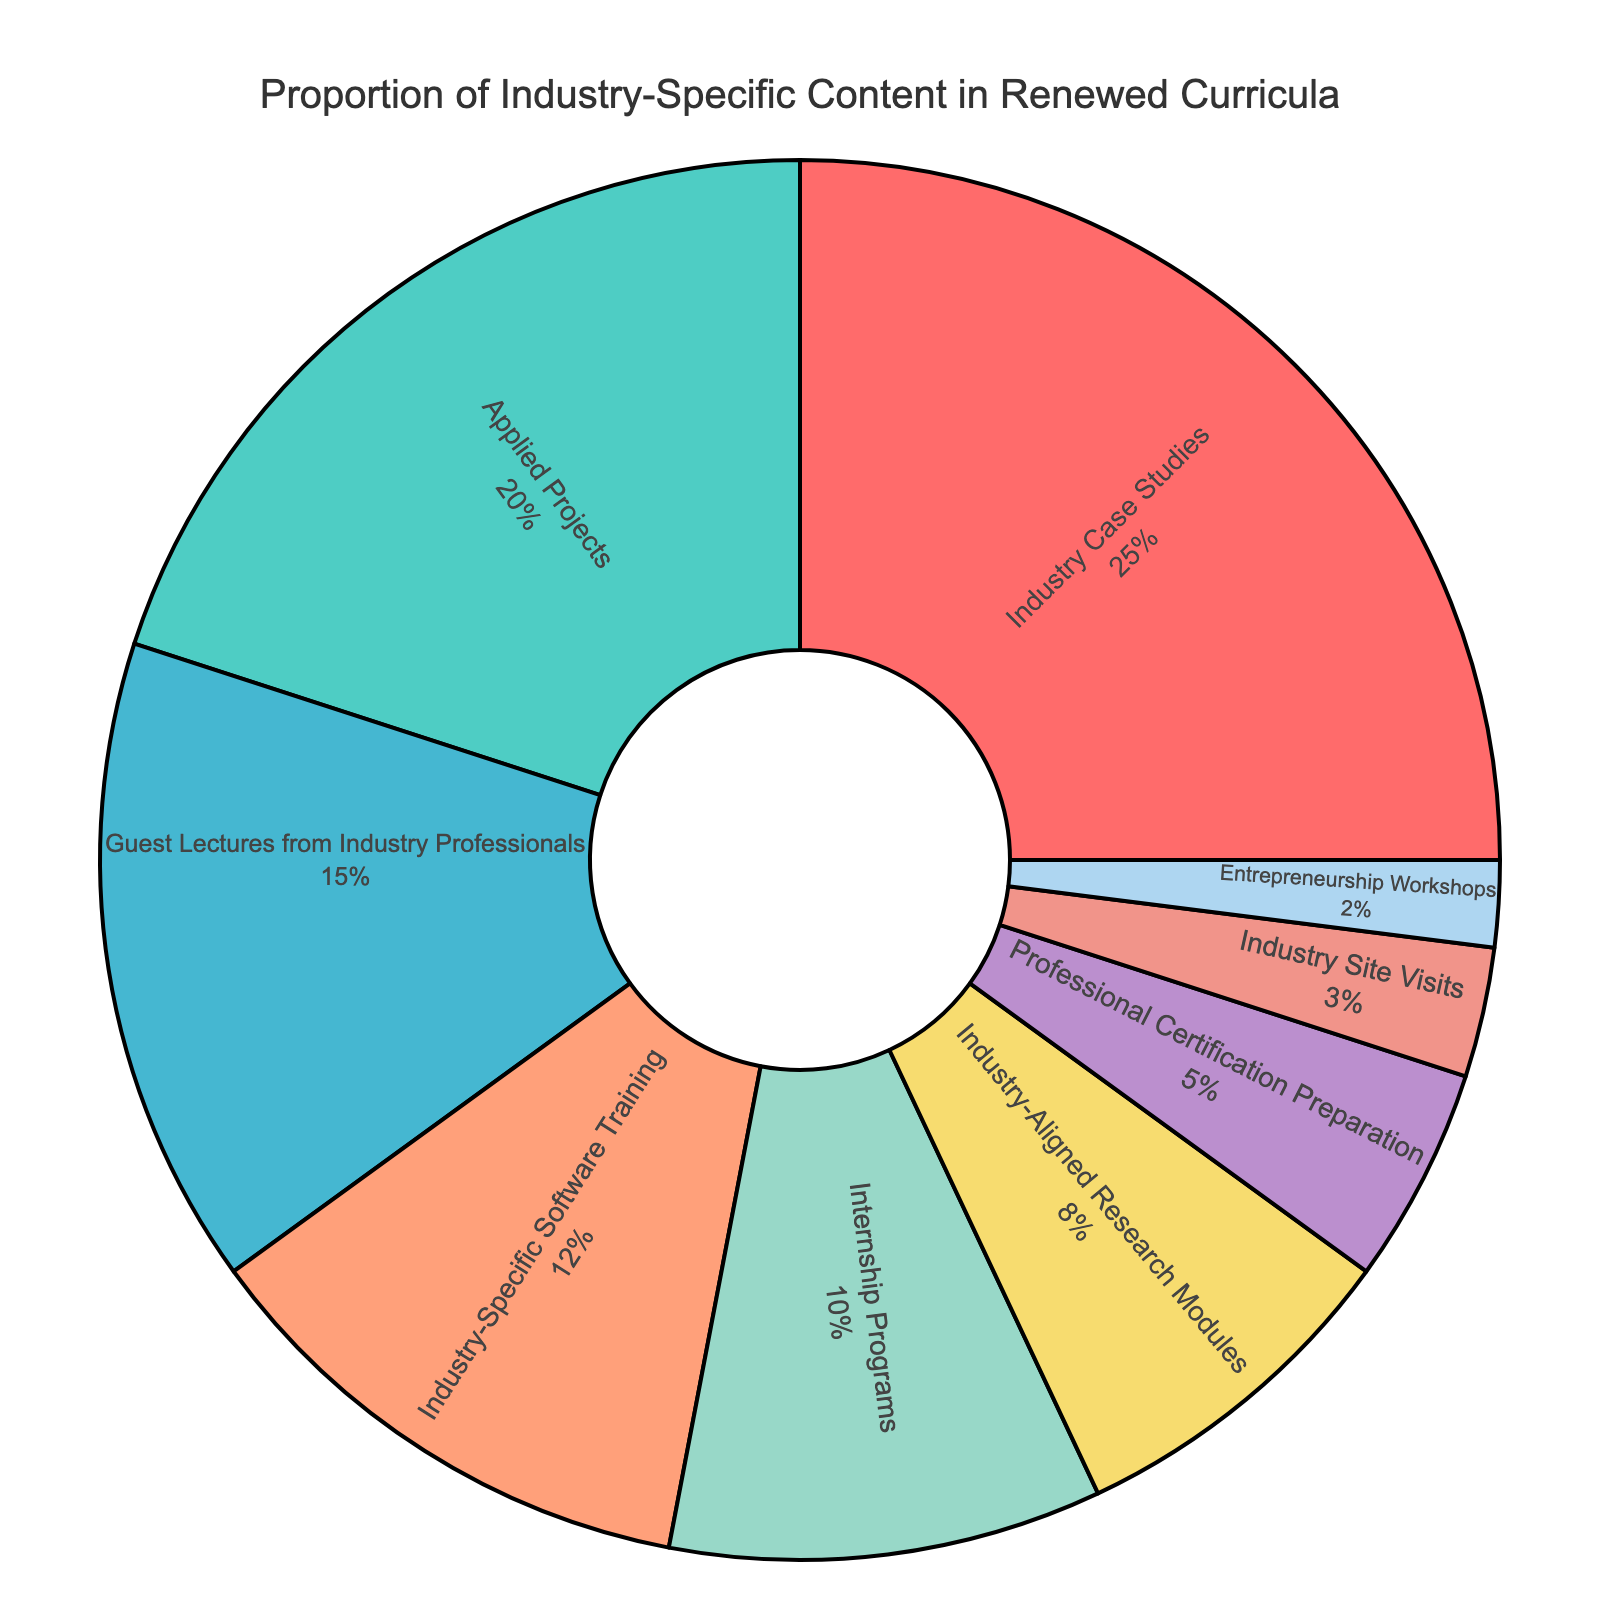Which course type has the highest proportion of industry-specific content? Referring to the figure, the course type with the largest segment represents the highest proportion. The largest segment is labeled "Industry Case Studies" with a percentage of 25%.
Answer: Industry Case Studies Which course types have a proportion that is greater than 10%? The segments labeled "Industry Case Studies" (25%), "Applied Projects" (20%), "Guest Lectures from Industry Professionals" (15%), and "Industry-Specific Software Training" (12%) have percentages greater than 10%.
Answer: Industry Case Studies, Applied Projects, Guest Lectures from Industry Professionals, Industry-Specific Software Training What is the combined proportion of "Internship Programs" and "Entrepreneurship Workshops"? The segment for "Internship Programs" is labeled 10%, and the segment for "Entrepreneurship Workshops" is labeled 2%. Adding these two percentages gives 10% + 2% = 12%.
Answer: 12% Which course type is represented by the smallest segment? The smallest segment visually in the pie chart is labeled "Entrepreneurship Workshops" with a percentage of 2%.
Answer: Entrepreneurship Workshops How many course types have a proportion less than or equal to 5%? The segments labeled "Professional Certification Preparation" (5%), "Industry Site Visits" (3%), and "Entrepreneurship Workshops" (2%) are all less than or equal to 5%. This totals to 3 course types.
Answer: 3 Which has a higher proportion: "Guest Lectures from Industry Professionals" or "Industry-Specific Software Training"? By comparing the segments, "Guest Lectures from Industry Professionals" is labeled 15%, while "Industry-Specific Software Training" is labeled 12%. Therefore, "Guest Lectures from Industry Professionals" has a higher proportion.
Answer: Guest Lectures from Industry Professionals What is the difference in proportion between "Applied Projects" and "Industry Site Visits"? The segment for "Applied Projects" is labeled 20%, and the segment for "Industry Site Visits" is labeled 3%. Subtracting these gives 20% - 3% = 17%.
Answer: 17% If you sum the proportions of the three smallest course types, what is the total? The smallest segments are "Entrepreneurship Workshops" (2%), "Industry Site Visits" (3%), and "Professional Certification Preparation" (5%). Adding these gives 2% + 3% + 5% =10%.
Answer: 10% Which is larger: The proportion of "Industry-Aligned Research Modules" or the sum of "Professional Certification Preparation" and "Industry Site Visits"? "Industry-Aligned Research Modules" is labeled 8%. The sum of "Professional Certification Preparation" (5%) and "Industry Site Visits" (3%) is 5% + 3% = 8%. Both proportions are equal.
Answer: Equal 